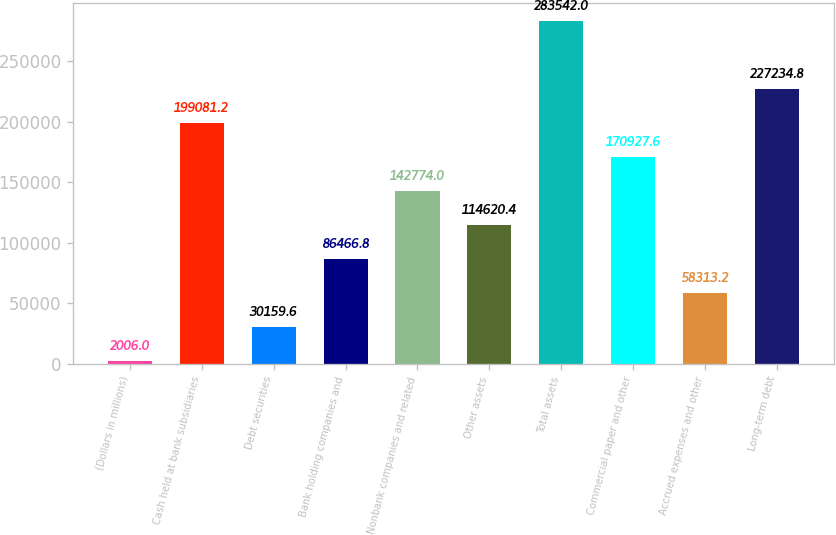Convert chart to OTSL. <chart><loc_0><loc_0><loc_500><loc_500><bar_chart><fcel>(Dollars in millions)<fcel>Cash held at bank subsidiaries<fcel>Debt securities<fcel>Bank holding companies and<fcel>Nonbank companies and related<fcel>Other assets<fcel>Total assets<fcel>Commercial paper and other<fcel>Accrued expenses and other<fcel>Long-term debt<nl><fcel>2006<fcel>199081<fcel>30159.6<fcel>86466.8<fcel>142774<fcel>114620<fcel>283542<fcel>170928<fcel>58313.2<fcel>227235<nl></chart> 